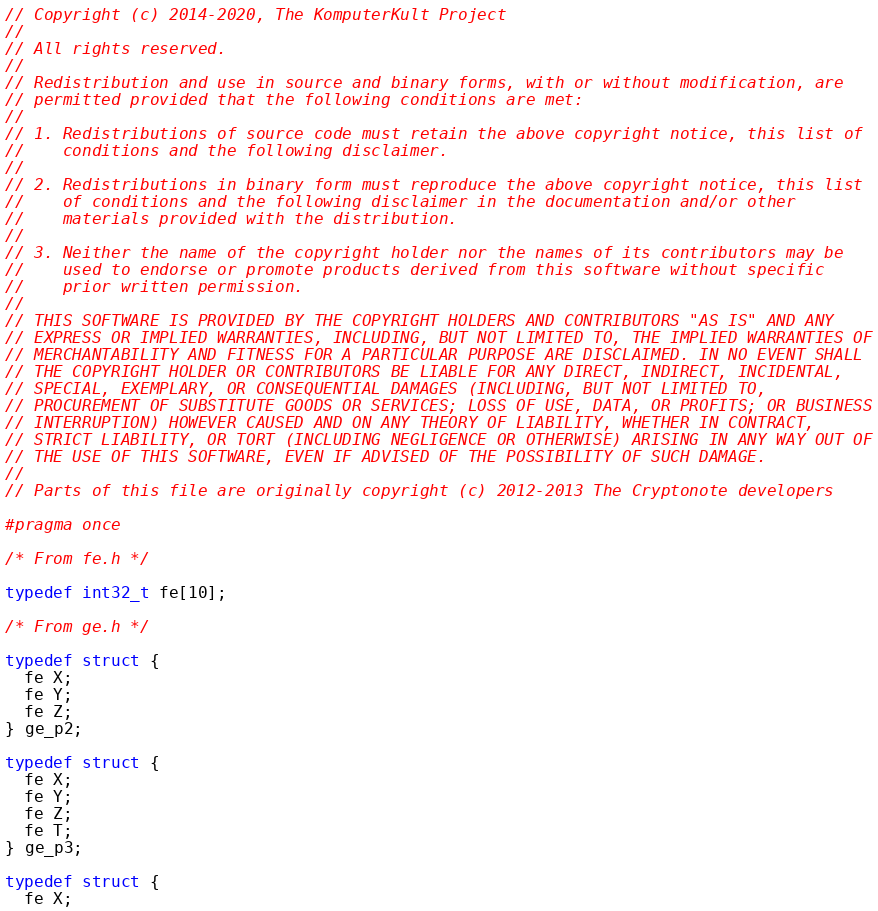Convert code to text. <code><loc_0><loc_0><loc_500><loc_500><_C_>// Copyright (c) 2014-2020, The KomputerKult Project
// 
// All rights reserved.
// 
// Redistribution and use in source and binary forms, with or without modification, are
// permitted provided that the following conditions are met:
// 
// 1. Redistributions of source code must retain the above copyright notice, this list of
//    conditions and the following disclaimer.
// 
// 2. Redistributions in binary form must reproduce the above copyright notice, this list
//    of conditions and the following disclaimer in the documentation and/or other
//    materials provided with the distribution.
// 
// 3. Neither the name of the copyright holder nor the names of its contributors may be
//    used to endorse or promote products derived from this software without specific
//    prior written permission.
// 
// THIS SOFTWARE IS PROVIDED BY THE COPYRIGHT HOLDERS AND CONTRIBUTORS "AS IS" AND ANY
// EXPRESS OR IMPLIED WARRANTIES, INCLUDING, BUT NOT LIMITED TO, THE IMPLIED WARRANTIES OF
// MERCHANTABILITY AND FITNESS FOR A PARTICULAR PURPOSE ARE DISCLAIMED. IN NO EVENT SHALL
// THE COPYRIGHT HOLDER OR CONTRIBUTORS BE LIABLE FOR ANY DIRECT, INDIRECT, INCIDENTAL,
// SPECIAL, EXEMPLARY, OR CONSEQUENTIAL DAMAGES (INCLUDING, BUT NOT LIMITED TO,
// PROCUREMENT OF SUBSTITUTE GOODS OR SERVICES; LOSS OF USE, DATA, OR PROFITS; OR BUSINESS
// INTERRUPTION) HOWEVER CAUSED AND ON ANY THEORY OF LIABILITY, WHETHER IN CONTRACT,
// STRICT LIABILITY, OR TORT (INCLUDING NEGLIGENCE OR OTHERWISE) ARISING IN ANY WAY OUT OF
// THE USE OF THIS SOFTWARE, EVEN IF ADVISED OF THE POSSIBILITY OF SUCH DAMAGE.
// 
// Parts of this file are originally copyright (c) 2012-2013 The Cryptonote developers

#pragma once

/* From fe.h */

typedef int32_t fe[10];

/* From ge.h */

typedef struct {
  fe X;
  fe Y;
  fe Z;
} ge_p2;

typedef struct {
  fe X;
  fe Y;
  fe Z;
  fe T;
} ge_p3;

typedef struct {
  fe X;</code> 